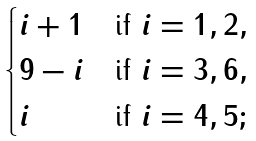<formula> <loc_0><loc_0><loc_500><loc_500>\begin{cases} i + 1 & \text {if } i = 1 , 2 , \\ 9 - i & \text {if } i = 3 , 6 , \\ i & \text {if } i = 4 , 5 ; \end{cases}</formula> 